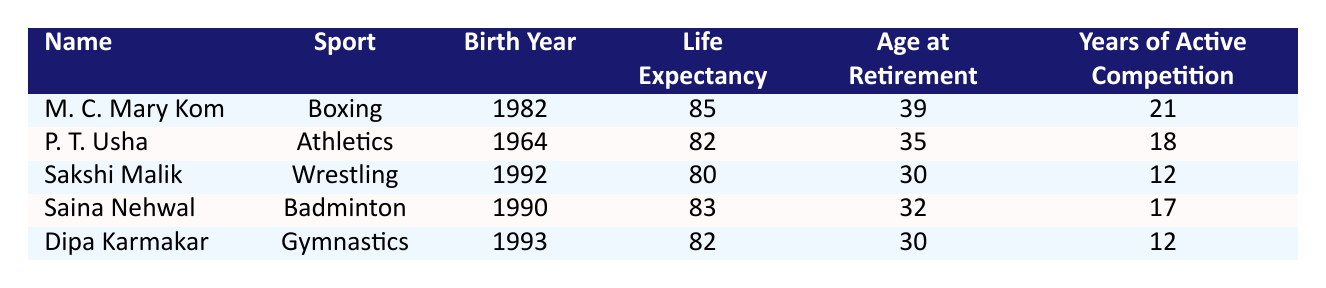What is the life expectancy of M. C. Mary Kom? According to the table, M. C. Mary Kom is listed with a life expectancy of 85 years.
Answer: 85 How many years did P. T. Usha compete actively? The table states that P. T. Usha had 18 years of active competition.
Answer: 18 Which athlete has the longest life expectancy? By comparing the life expectancies listed, M. C. Mary Kom has the longest life expectancy at 85 years.
Answer: M. C. Mary Kom Is the age at retirement for Saina Nehwal greater than or equal to 32? The age at retirement for Saina Nehwal is 32, which means it is equal, so the answer is yes.
Answer: Yes What is the average life expectancy of all athletes listed? To find the average, we add the life expectancies: (85 + 82 + 80 + 83 + 82) = 412. There are 5 athletes, so the average is 412/5 = 82.4.
Answer: 82.4 What is the age difference between the oldest and youngest athlete at retirement? The oldest athlete at retirement is P. T. Usha (35) and the youngest is Sakshi Malik (30). The age difference is 35 - 30 = 5 years.
Answer: 5 How many total years of active competition do the athletes have combined? Summing the years of active competition: (21 + 18 + 12 + 17 + 12) = 80 years in total.
Answer: 80 Is it true that Dipa Karmakar retired at the age of 30? The table shows Dipa Karmakar's age at retirement is 30, confirming the statement is true.
Answer: Yes What sport has the highest life expectancy among the listed athletes? By checking the life expectancy, boxing (M. C. Mary Kom) with 85 years has the highest life expectancy.
Answer: Boxing 